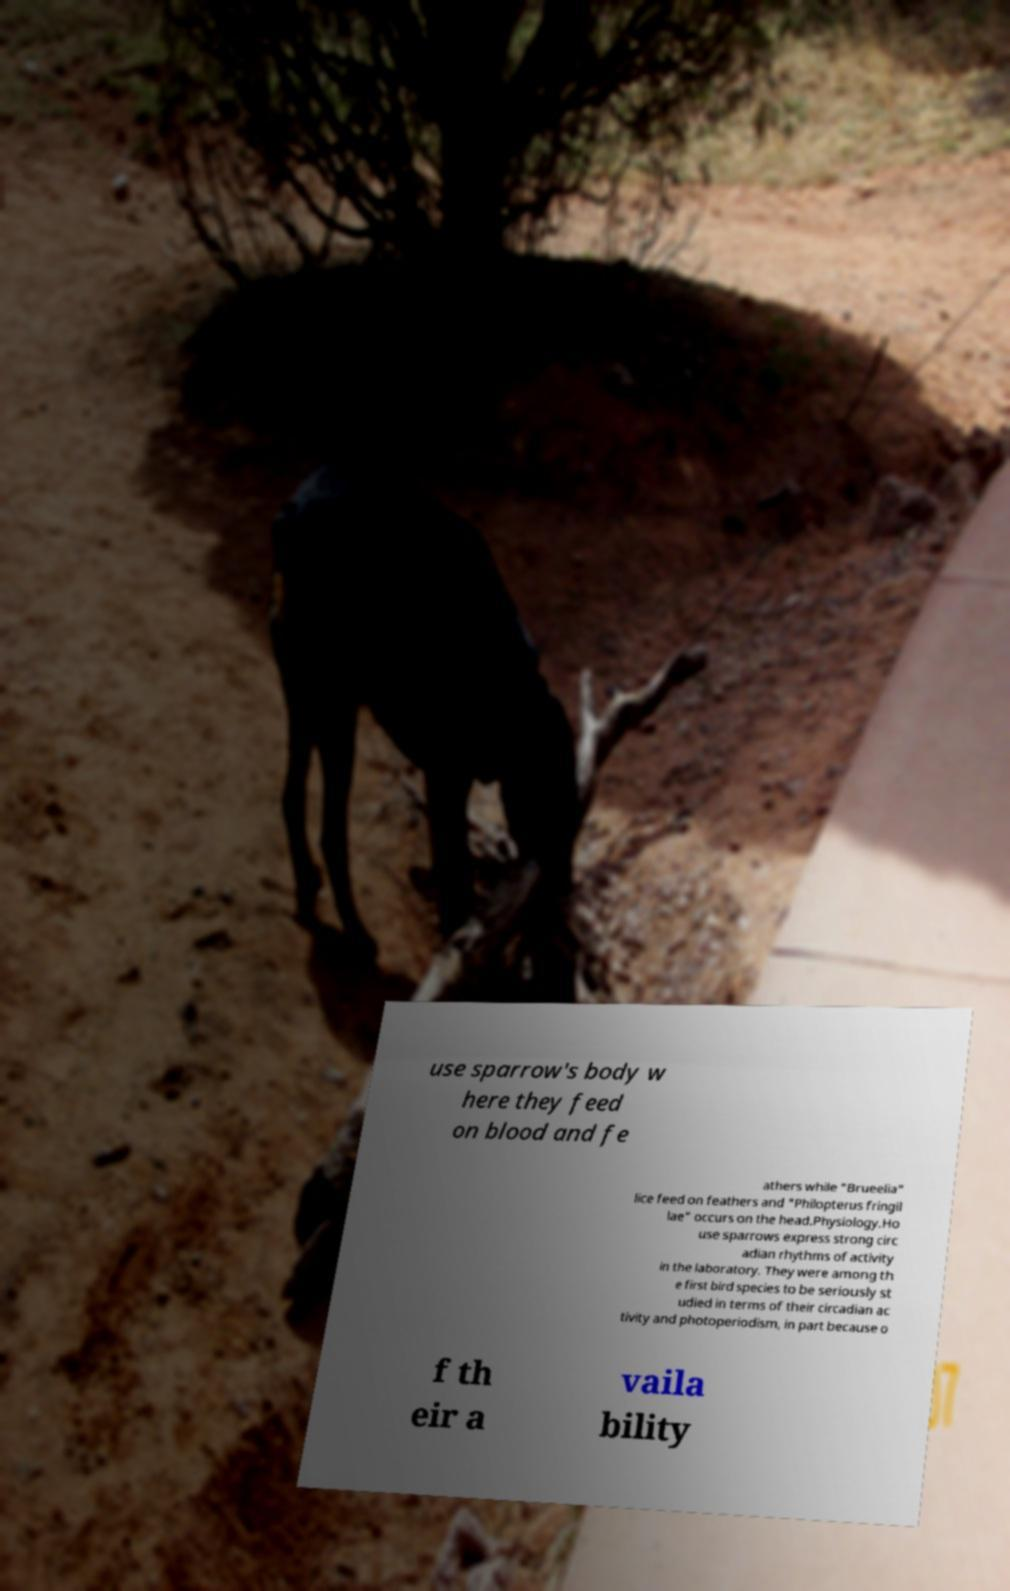Can you read and provide the text displayed in the image?This photo seems to have some interesting text. Can you extract and type it out for me? use sparrow's body w here they feed on blood and fe athers while "Brueelia" lice feed on feathers and "Philopterus fringil lae" occurs on the head.Physiology.Ho use sparrows express strong circ adian rhythms of activity in the laboratory. They were among th e first bird species to be seriously st udied in terms of their circadian ac tivity and photoperiodism, in part because o f th eir a vaila bility 